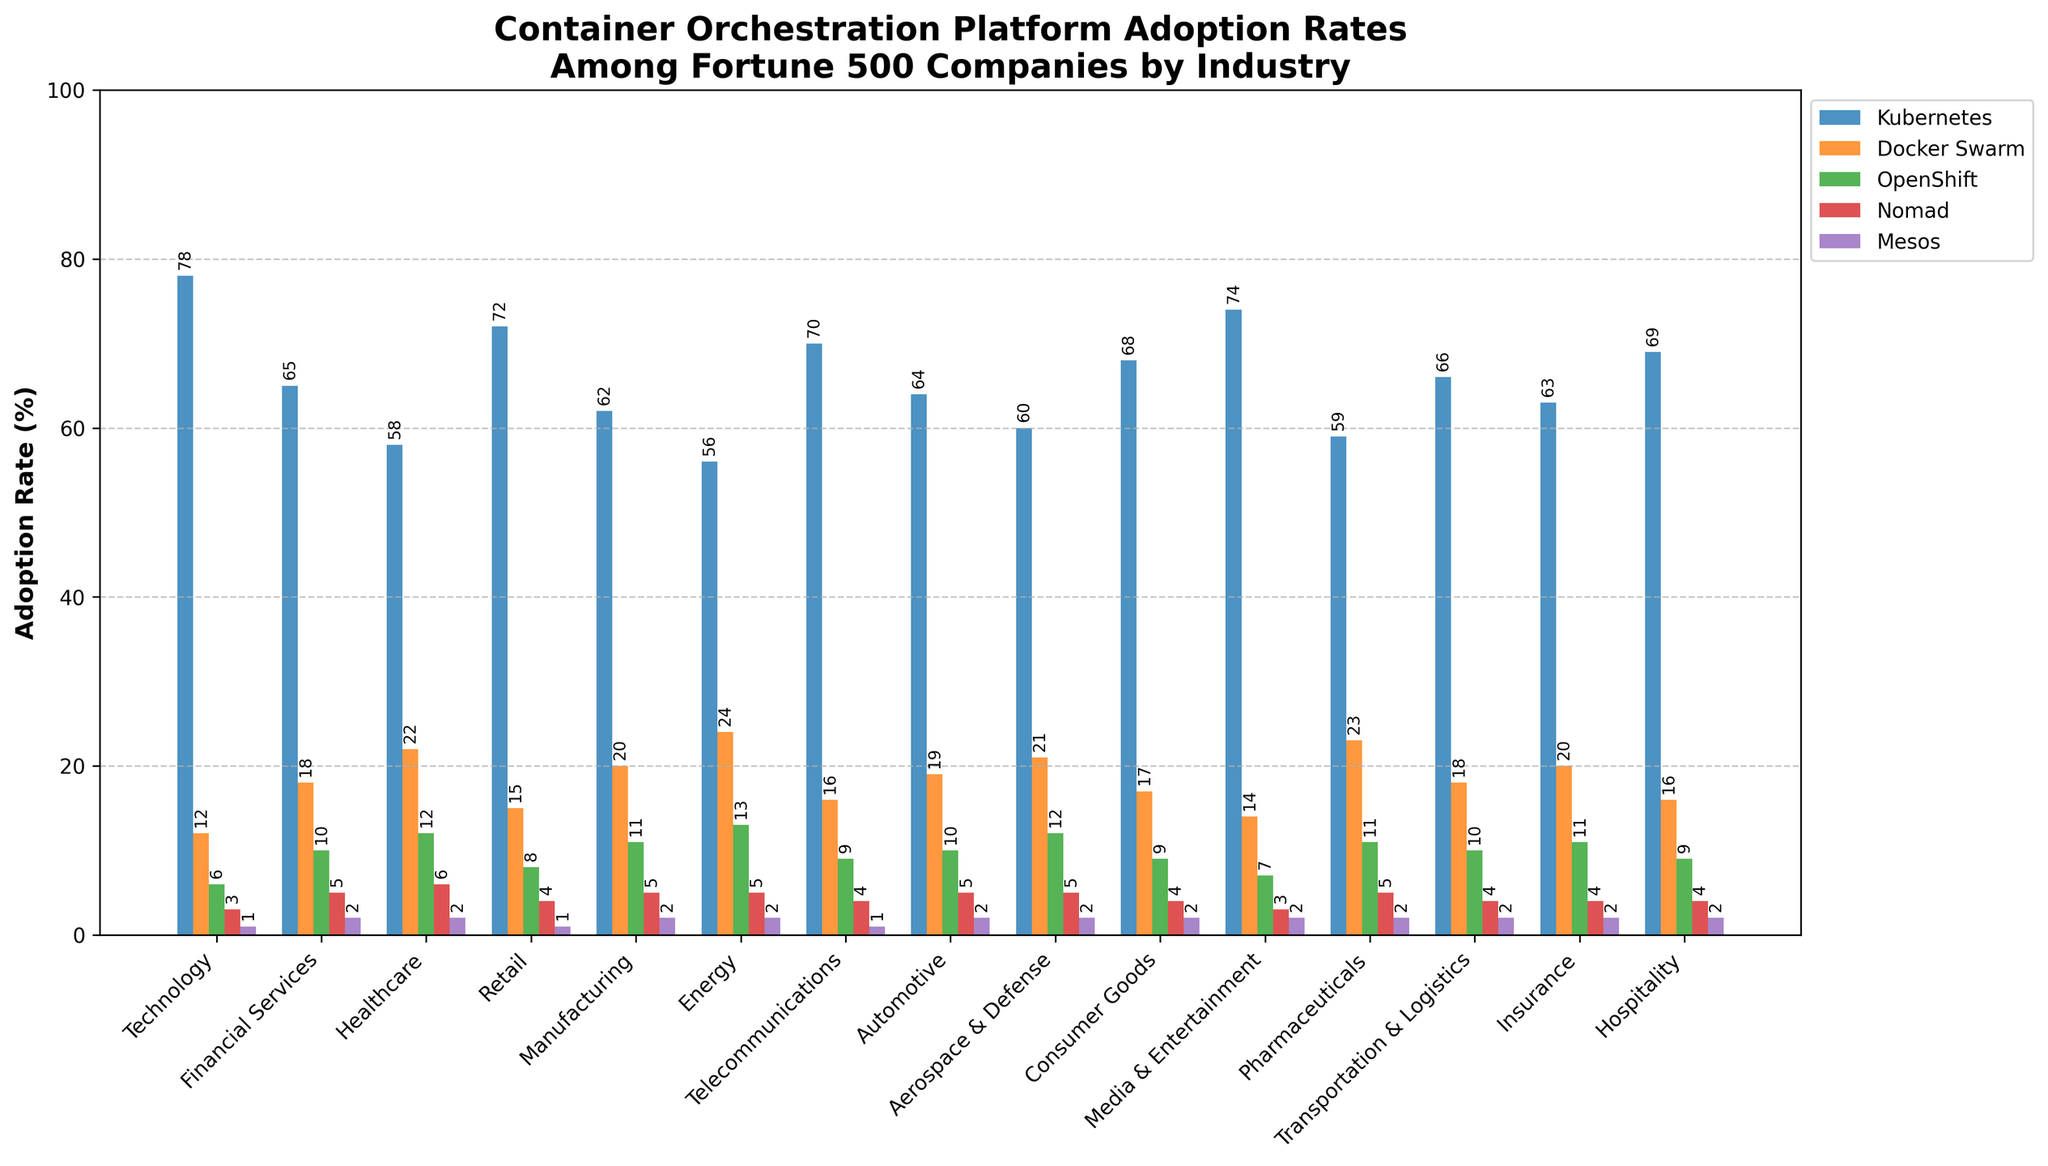Which industry has the highest adoption rate for Kubernetes? The bar chart shows that the Technology industry has the highest Kubernetes adoption rate, at 78%.
Answer: Technology What is the sum of Docker Swarm adoption rates in the Financial Services and Healthcare industries? The Docker Swarm adoption rate for Financial Services is 18%, and for Healthcare, it is 22%. The sum is 18 + 22.
Answer: 40% Which container orchestration platform has the lowest adoption rate across all industries? By examining all the bars in the chart, we can see that Mesos has the lowest adoption rate across all industries, with the highest being only 2%.
Answer: Mesos How does the Nomad adoption rate in the Retail industry compare to that in the Media & Entertainment industry? The Retail industry has a Nomad adoption rate of 4%, while the Media & Entertainment industry has a Nomad adoption rate of 3%. Therefore, Retail is higher by 1%.
Answer: Retail is higher What is the average Kubernetes adoption rate across all industries? Sum all the Kubernetes adoption rates (78 + 65 + 58 + 72 + 62 + 56 + 70 + 64 + 60 + 68 + 74 + 59 + 66 + 63 + 69) = 1014 and divide by the number of industries (15). Average = 1014 / 15.
Answer: 67.6% Which industry has the smallest difference in adoption rates between Kubernetes and OpenShift? Compute the difference for each industry and identify the smallest one. Technology: 72, Financial Services: 55, Healthcare: 46, Retail: 64, Manufacturing: 51, Energy: 43, Telecommunications: 61, Automotive: 54, Aerospace & Defense: 48, Consumer Goods: 59, Media & Entertainment: 67, Pharmaceuticals: 48, Transportation & Logistics: 56, Insurance: 52, Hospitality: 60. The smallest difference is in Energy (43).
Answer: Energy Which industry shows a higher Docker Swarm adoption rate than OpenShift adoption rate? Compare the heights of the Docker Swarm and OpenShift bars for each industry. Healthcare and Energy both show higher Docker Swarm adoption rates than OpenShift (Healthcare: 22 vs. 12, Energy: 24 vs. 13).
Answer: Healthcare and Energy What is the total adoption rate for all platforms in the Automotive industry? Sum the adoption rates of Kubernetes, Docker Swarm, OpenShift, Nomad, and Mesos in the Automotive industry (64 + 19 + 10 + 5 + 2).
Answer: 100% What is the most common color used to represent the bars in the chart? Visually inspect the bars and see that blue is the most common color, representing the tallest bars for Kubernetes in almost every industry.
Answer: Blue Which industry has the greatest range (difference between highest and lowest values) in adoption rates across all platforms? Calculate the range for each industry and identify the greatest one. Automotive: 62 (64-2), Financial Services: 63 (65-2), Technology: 77 (78-1), etc. The Technology industry has the greatest range.
Answer: Technology 